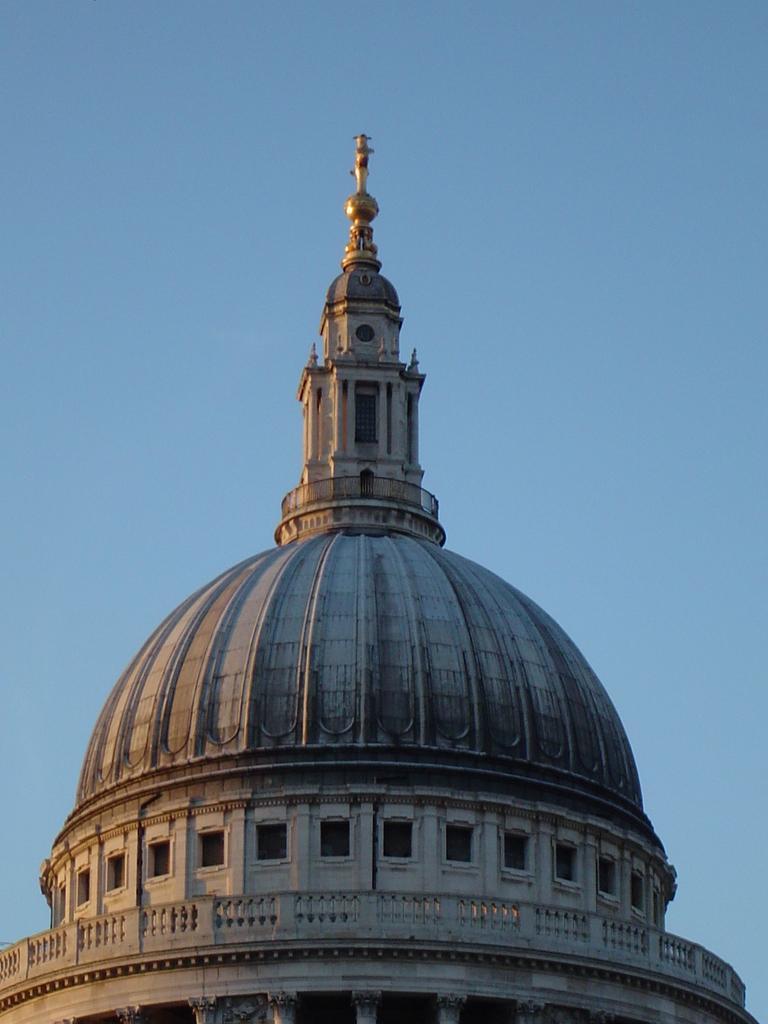In one or two sentences, can you explain what this image depicts? In the picture I can see a building. In the background I can see the sky. 